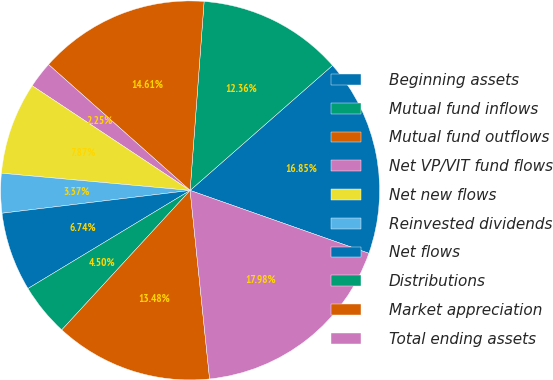Convert chart. <chart><loc_0><loc_0><loc_500><loc_500><pie_chart><fcel>Beginning assets<fcel>Mutual fund inflows<fcel>Mutual fund outflows<fcel>Net VP/VIT fund flows<fcel>Net new flows<fcel>Reinvested dividends<fcel>Net flows<fcel>Distributions<fcel>Market appreciation<fcel>Total ending assets<nl><fcel>16.85%<fcel>12.36%<fcel>14.61%<fcel>2.25%<fcel>7.87%<fcel>3.37%<fcel>6.74%<fcel>4.5%<fcel>13.48%<fcel>17.98%<nl></chart> 